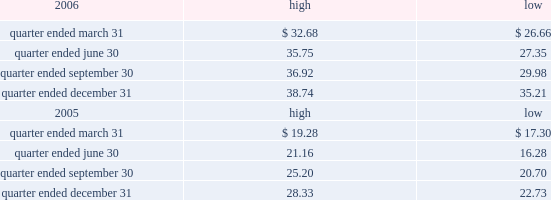Part ii item 5 .
Market for registrant 2019s common equity , related stockholder matters and issuer purchases of equity securities the table presents reported quarterly high and low per share sale prices of our class a common stock on the new york stock exchange ( nyse ) for the years 2006 and 2005. .
On february 22 , 2007 , the closing price of our class a common stock was $ 40.38 per share as reported on the nyse .
As of february 22 , 2007 , we had 419988395 outstanding shares of class a common stock and 623 registered holders .
In february 2004 , all outstanding shares of our class b common stock were converted into shares of our class a common stock on a one-for-one basis pursuant to the occurrence of the 201cdodge conversion event 201d as defined in our charter .
Also in february 2004 , all outstanding shares of class c common stock were converted into shares of class a common stock on a one-for-one basis .
In august 2005 , we amended and restated our charter to , among other things , eliminate our class b common stock and class c common stock .
Dividends we have never paid a dividend on any class of our common stock .
We anticipate that we may retain future earnings , if any , to fund the development and growth of our business .
The indentures governing our 7.50% ( 7.50 % ) senior notes due 2012 ( 7.50% ( 7.50 % ) notes ) and our 7.125% ( 7.125 % ) senior notes due 2012 ( 7.125% ( 7.125 % ) notes ) may prohibit us from paying dividends to our stockholders unless we satisfy certain financial covenants .
Our credit facilities and the indentures governing the terms of our debt securities contain covenants that may restrict the ability of our subsidiaries from making to us any direct or indirect distribution , dividend or other payment on account of their limited liability company interests , partnership interests , capital stock or other equity interests .
Under our credit facilities , the borrower subsidiaries may pay cash dividends or make other distributions to us in accordance with the applicable credit facility only if no default exists or would be created thereby .
The indenture governing the terms of the ati 7.25% ( 7.25 % ) notes prohibit ati and certain of our other subsidiaries that have guaranteed those notes ( sister guarantors ) from paying dividends and making other payments or distributions to us unless certain financial covenants are satisfied .
The indentures governing the terms of our 7.50% ( 7.50 % ) notes and 7.125% ( 7.125 % ) notes also contain certain restrictive covenants , which prohibit the restricted subsidiaries under these indentures from paying dividends and making other payments or distributions to us unless certain financial covenants are satisfied .
For more information about the restrictions under our credit facilities and our notes indentures , see item 7 of this annual report under the caption 201cmanagement 2019s discussion and analysis of financial condition and results of operations 2014liquidity and capital resources 2014factors affecting sources of liquidity 201d and note 7 to our consolidated financial statements included in this annual report. .
What is the average number of shares per registered holder as of february 22 , 2007? 
Computations: (419988395 / 623)
Answer: 674138.67576. 